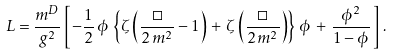Convert formula to latex. <formula><loc_0><loc_0><loc_500><loc_500>L = \frac { m ^ { D } } { g ^ { 2 } } \left [ \, - \frac { 1 } { 2 } \, \phi \, \left \{ \zeta \left ( { \frac { \Box } { 2 \, m ^ { 2 } } - 1 } \right ) \, + \, \zeta \left ( { \frac { \Box } { 2 \, m ^ { 2 } } } \right ) \right \} \, \phi \, + \, \frac { \phi ^ { 2 } } { 1 - \phi } \, \right ] \, .</formula> 